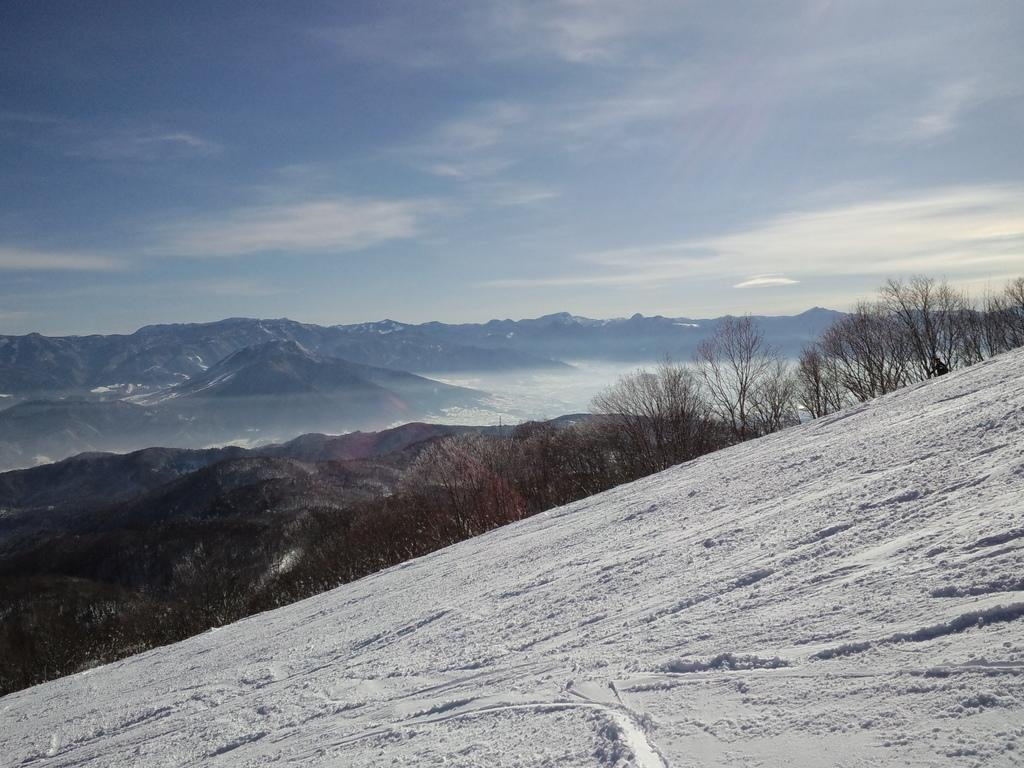What type of natural features can be seen in the image? There are trees, water, and mountains visible in the image. What is visible at the top of the image? The sky is visible at the top of the image. Can you describe the setting of the image? The image may have been taken near the mountains, as they are prominently featured. How many girls are observing the mountain in the image? There are no girls present in the image; it features trees, water, mountains, and the sky. 